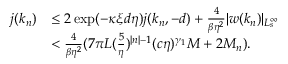<formula> <loc_0><loc_0><loc_500><loc_500>\begin{array} { r l } { j ( k _ { n } ) } & { \leq 2 \exp ( - \kappa \xi d \eta ) j ( k _ { n } , - d ) + \frac { 4 } \beta \eta ^ { 2 } } | w ( k _ { n } ) | _ { L _ { s } ^ { \infty } } } \\ & { < \frac { 4 } \beta \eta ^ { 2 } } ( 7 \pi L ( \frac { 5 } { \eta } ) ^ { | n | - 1 } ( c \eta ) ^ { \gamma _ { 1 } } M + 2 M _ { n } ) . } \end{array}</formula> 